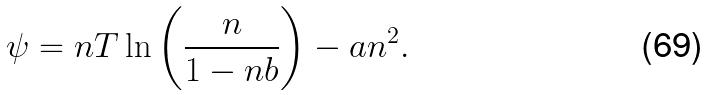<formula> <loc_0><loc_0><loc_500><loc_500>\psi = n T \ln \left ( \frac { n } { 1 - n b } \right ) - a n ^ { 2 } .</formula> 